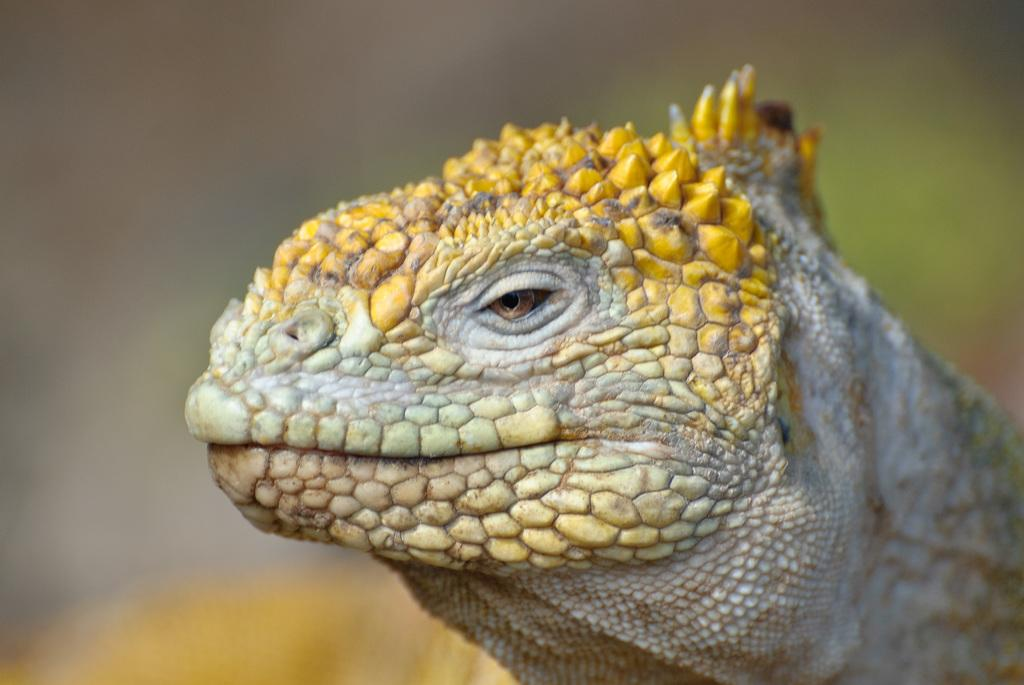What type of animal is in the picture? There is a reptile in the picture. Can you describe the background of the image? The background of the image is blurred. What team does the guide wear a shirt for in the image? There is no guide or shirt present in the image; it only features a reptile and a blurred background. 